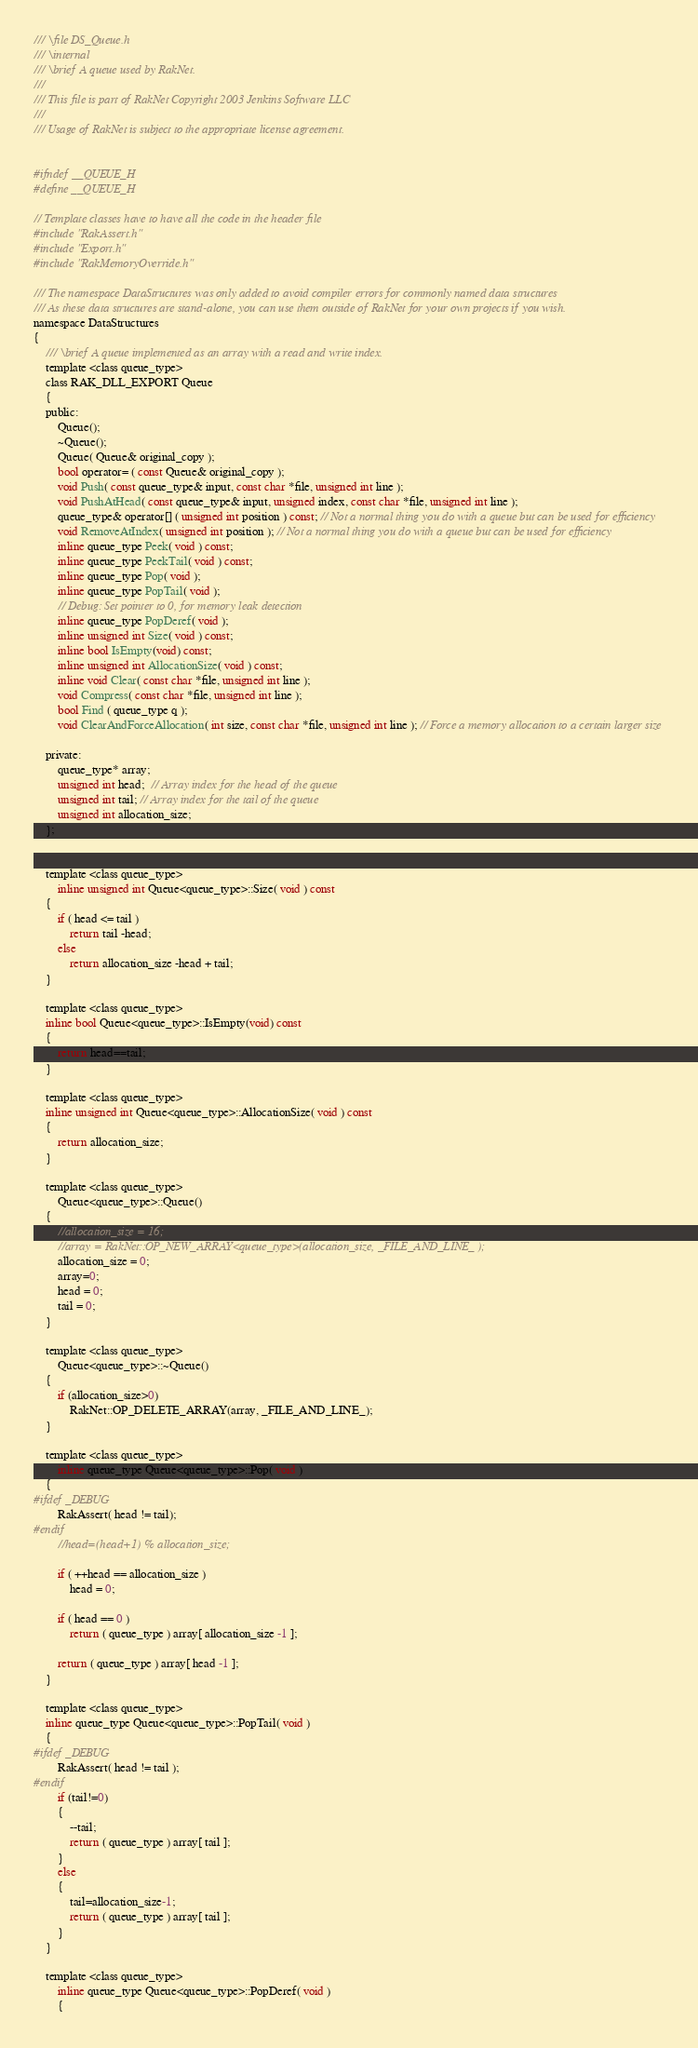<code> <loc_0><loc_0><loc_500><loc_500><_C_>/// \file DS_Queue.h
/// \internal
/// \brief A queue used by RakNet.
///
/// This file is part of RakNet Copyright 2003 Jenkins Software LLC
///
/// Usage of RakNet is subject to the appropriate license agreement.


#ifndef __QUEUE_H
#define __QUEUE_H

// Template classes have to have all the code in the header file
#include "RakAssert.h"
#include "Export.h"
#include "RakMemoryOverride.h"

/// The namespace DataStructures was only added to avoid compiler errors for commonly named data structures
/// As these data structures are stand-alone, you can use them outside of RakNet for your own projects if you wish.
namespace DataStructures
{
	/// \brief A queue implemented as an array with a read and write index.
	template <class queue_type>
	class RAK_DLL_EXPORT Queue
	{
	public:
		Queue();
		~Queue();
		Queue( Queue& original_copy );
		bool operator= ( const Queue& original_copy );
		void Push( const queue_type& input, const char *file, unsigned int line );
		void PushAtHead( const queue_type& input, unsigned index, const char *file, unsigned int line );
		queue_type& operator[] ( unsigned int position ) const; // Not a normal thing you do with a queue but can be used for efficiency
		void RemoveAtIndex( unsigned int position ); // Not a normal thing you do with a queue but can be used for efficiency
		inline queue_type Peek( void ) const;
		inline queue_type PeekTail( void ) const;
		inline queue_type Pop( void );
		inline queue_type PopTail( void );
		// Debug: Set pointer to 0, for memory leak detection
		inline queue_type PopDeref( void );
		inline unsigned int Size( void ) const;
		inline bool IsEmpty(void) const;
		inline unsigned int AllocationSize( void ) const;
		inline void Clear( const char *file, unsigned int line );
		void Compress( const char *file, unsigned int line );
		bool Find ( queue_type q );
		void ClearAndForceAllocation( int size, const char *file, unsigned int line ); // Force a memory allocation to a certain larger size

	private:
		queue_type* array;
		unsigned int head;  // Array index for the head of the queue
		unsigned int tail; // Array index for the tail of the queue
		unsigned int allocation_size;
	};


	template <class queue_type>
		inline unsigned int Queue<queue_type>::Size( void ) const
	{
		if ( head <= tail )
			return tail -head;
		else
			return allocation_size -head + tail;
	}

	template <class queue_type>
	inline bool Queue<queue_type>::IsEmpty(void) const
	{
		return head==tail;
	}

	template <class queue_type>
	inline unsigned int Queue<queue_type>::AllocationSize( void ) const
	{
		return allocation_size;
	}

	template <class queue_type>
		Queue<queue_type>::Queue()
	{
		//allocation_size = 16;
		//array = RakNet::OP_NEW_ARRAY<queue_type>(allocation_size, _FILE_AND_LINE_ );
		allocation_size = 0;
		array=0;
		head = 0;
		tail = 0;
	}

	template <class queue_type>
		Queue<queue_type>::~Queue()
	{
		if (allocation_size>0)
			RakNet::OP_DELETE_ARRAY(array, _FILE_AND_LINE_);
	}

	template <class queue_type>
		inline queue_type Queue<queue_type>::Pop( void )
	{
#ifdef _DEBUG
		RakAssert( head != tail);
#endif
		//head=(head+1) % allocation_size;

		if ( ++head == allocation_size )
			head = 0;

		if ( head == 0 )
			return ( queue_type ) array[ allocation_size -1 ];

		return ( queue_type ) array[ head -1 ];
	}

	template <class queue_type>
	inline queue_type Queue<queue_type>::PopTail( void )
	{
#ifdef _DEBUG
		RakAssert( head != tail );
#endif
		if (tail!=0)
		{
			--tail;
			return ( queue_type ) array[ tail ];
		}
		else
		{
			tail=allocation_size-1;
			return ( queue_type ) array[ tail ];
		}
	}

	template <class queue_type>
		inline queue_type Queue<queue_type>::PopDeref( void )
		{</code> 